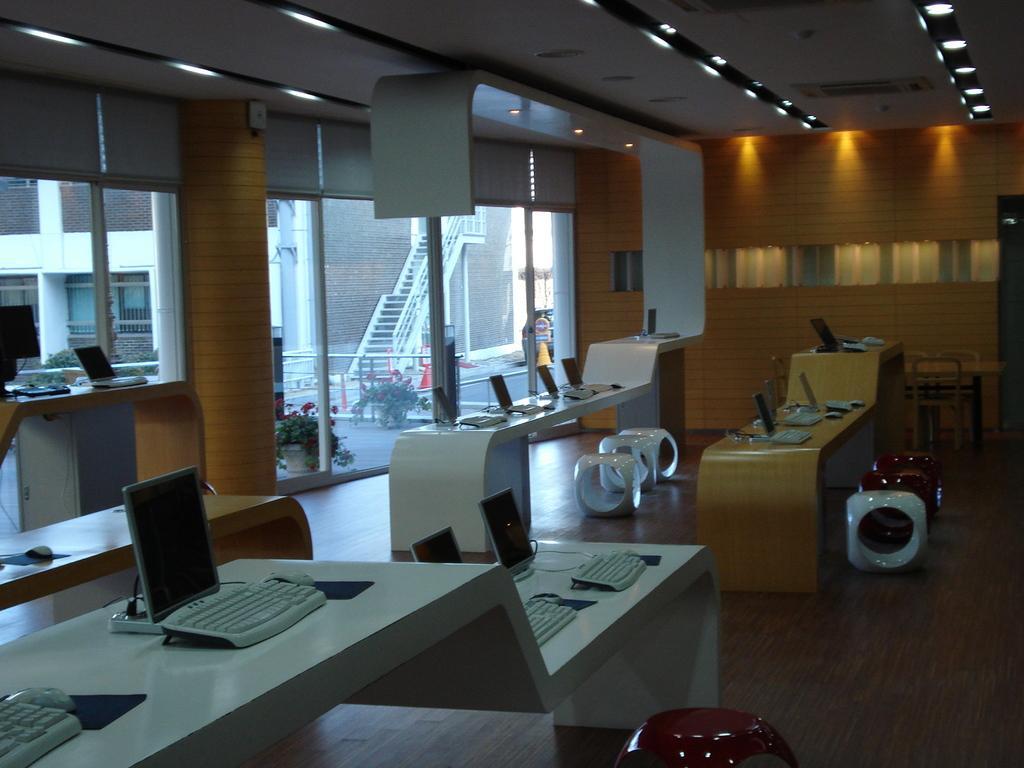Please provide a concise description of this image. Here in this picture we can see number of tables with monitors, keyboards and mouses present on it and we can also see some different kind of stools present on the floor and on the left side we can see glass doors present, through which we can see other buildings and a staircase present and we can also see plants present outside and we can see lights on the roof. 